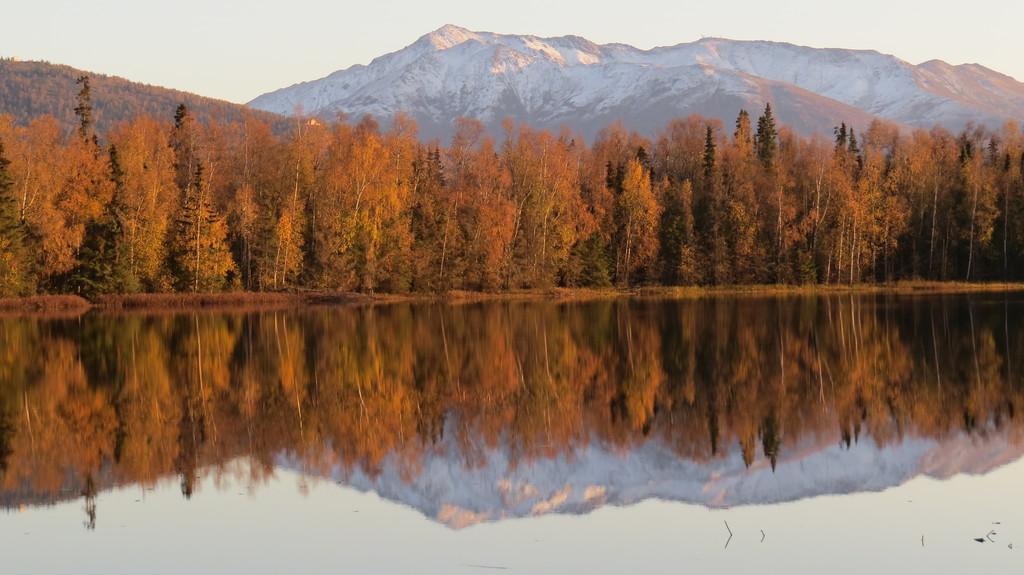Can you describe this image briefly? In this picture I can see water, there are trees, there are snow mountains, and in the background there is the sky. 